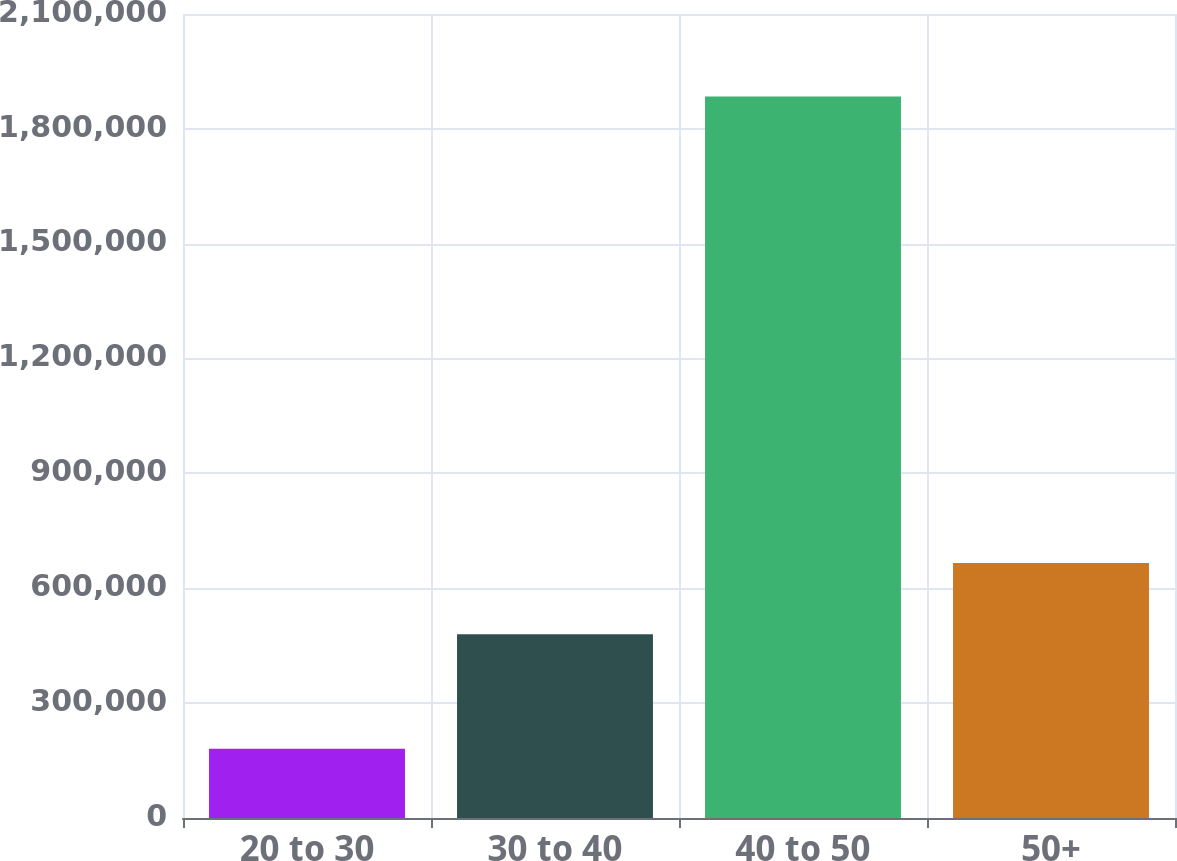Convert chart. <chart><loc_0><loc_0><loc_500><loc_500><bar_chart><fcel>20 to 30<fcel>30 to 40<fcel>40 to 50<fcel>50+<nl><fcel>180573<fcel>480164<fcel>1.88458e+06<fcel>665800<nl></chart> 